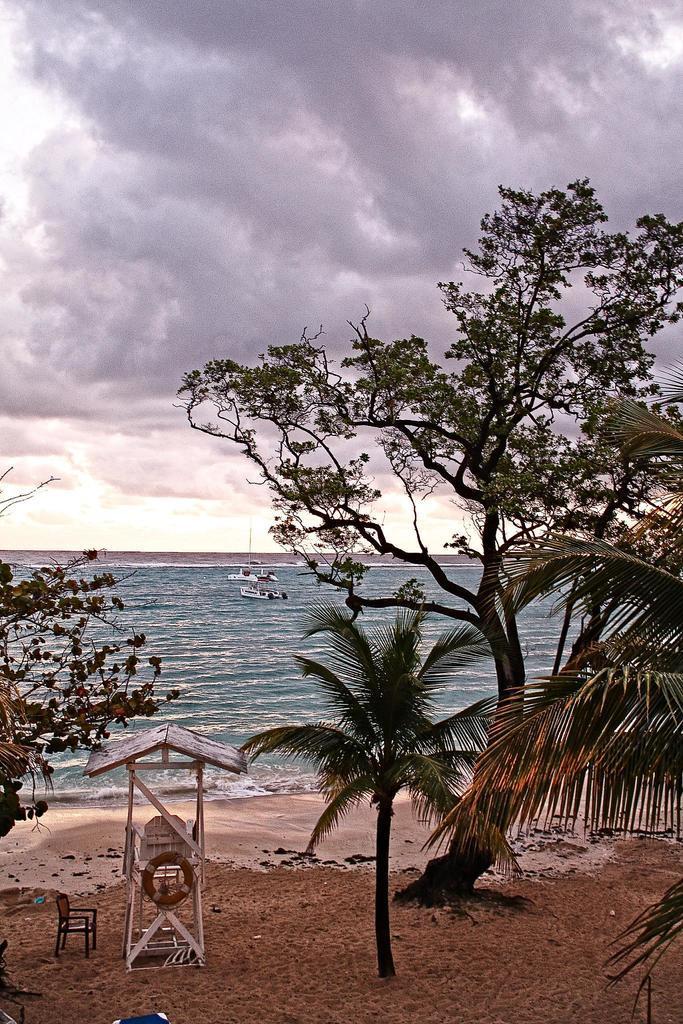How would you summarize this image in a sentence or two? In this image there is water in the middle. Beside the water there is a beach. In the beach there are trees and a small wooden hut. Beside the hut there is a chair. There are few board in the water. At the top there is the sky. On the ground there is sand. 